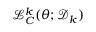<formula> <loc_0><loc_0><loc_500><loc_500>\mathcal { L } _ { C } ^ { k } ( \theta ; \mathcal { D } _ { k } )</formula> 